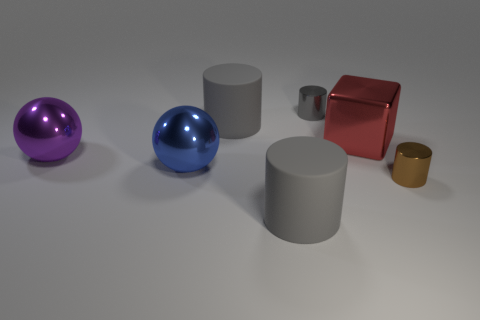Add 2 small things. How many objects exist? 9 Subtract all small brown cylinders. How many cylinders are left? 3 Subtract all brown cylinders. How many cylinders are left? 3 Subtract all cylinders. How many objects are left? 3 Subtract all small red rubber balls. Subtract all large red blocks. How many objects are left? 6 Add 7 purple spheres. How many purple spheres are left? 8 Add 7 gray cylinders. How many gray cylinders exist? 10 Subtract 0 gray balls. How many objects are left? 7 Subtract 3 cylinders. How many cylinders are left? 1 Subtract all gray cylinders. Subtract all green blocks. How many cylinders are left? 1 